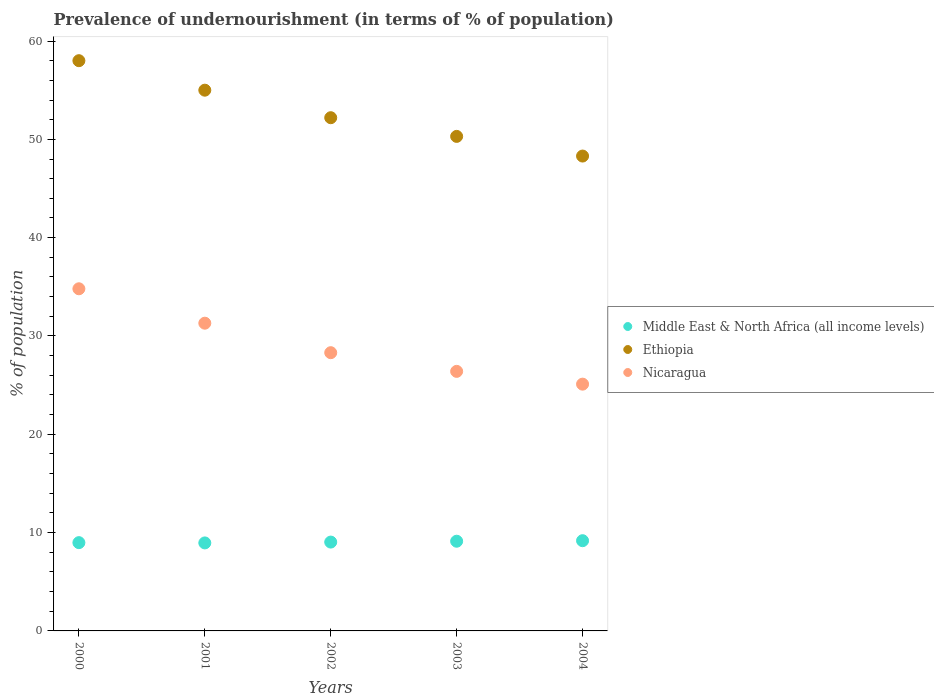How many different coloured dotlines are there?
Offer a terse response. 3. Is the number of dotlines equal to the number of legend labels?
Your response must be concise. Yes. What is the percentage of undernourished population in Middle East & North Africa (all income levels) in 2000?
Give a very brief answer. 8.98. Across all years, what is the maximum percentage of undernourished population in Ethiopia?
Ensure brevity in your answer.  58. Across all years, what is the minimum percentage of undernourished population in Ethiopia?
Your answer should be compact. 48.3. In which year was the percentage of undernourished population in Ethiopia minimum?
Your answer should be very brief. 2004. What is the total percentage of undernourished population in Middle East & North Africa (all income levels) in the graph?
Ensure brevity in your answer.  45.27. What is the difference between the percentage of undernourished population in Middle East & North Africa (all income levels) in 2003 and that in 2004?
Give a very brief answer. -0.05. What is the difference between the percentage of undernourished population in Ethiopia in 2004 and the percentage of undernourished population in Middle East & North Africa (all income levels) in 2001?
Your answer should be compact. 39.35. What is the average percentage of undernourished population in Ethiopia per year?
Ensure brevity in your answer.  52.76. In the year 2002, what is the difference between the percentage of undernourished population in Ethiopia and percentage of undernourished population in Middle East & North Africa (all income levels)?
Your answer should be compact. 43.16. What is the ratio of the percentage of undernourished population in Ethiopia in 2002 to that in 2004?
Your answer should be compact. 1.08. Is the difference between the percentage of undernourished population in Ethiopia in 2003 and 2004 greater than the difference between the percentage of undernourished population in Middle East & North Africa (all income levels) in 2003 and 2004?
Keep it short and to the point. Yes. What is the difference between the highest and the second highest percentage of undernourished population in Nicaragua?
Your answer should be very brief. 3.5. What is the difference between the highest and the lowest percentage of undernourished population in Ethiopia?
Ensure brevity in your answer.  9.7. Is the percentage of undernourished population in Middle East & North Africa (all income levels) strictly greater than the percentage of undernourished population in Ethiopia over the years?
Offer a terse response. No. How many dotlines are there?
Keep it short and to the point. 3. Does the graph contain grids?
Provide a succinct answer. No. How many legend labels are there?
Provide a short and direct response. 3. How are the legend labels stacked?
Offer a very short reply. Vertical. What is the title of the graph?
Give a very brief answer. Prevalence of undernourishment (in terms of % of population). Does "Spain" appear as one of the legend labels in the graph?
Offer a very short reply. No. What is the label or title of the Y-axis?
Your response must be concise. % of population. What is the % of population of Middle East & North Africa (all income levels) in 2000?
Keep it short and to the point. 8.98. What is the % of population of Ethiopia in 2000?
Give a very brief answer. 58. What is the % of population of Nicaragua in 2000?
Keep it short and to the point. 34.8. What is the % of population of Middle East & North Africa (all income levels) in 2001?
Offer a terse response. 8.95. What is the % of population in Ethiopia in 2001?
Offer a terse response. 55. What is the % of population in Nicaragua in 2001?
Your response must be concise. 31.3. What is the % of population in Middle East & North Africa (all income levels) in 2002?
Give a very brief answer. 9.04. What is the % of population of Ethiopia in 2002?
Offer a terse response. 52.2. What is the % of population in Nicaragua in 2002?
Give a very brief answer. 28.3. What is the % of population in Middle East & North Africa (all income levels) in 2003?
Your answer should be very brief. 9.12. What is the % of population of Ethiopia in 2003?
Provide a succinct answer. 50.3. What is the % of population of Nicaragua in 2003?
Provide a short and direct response. 26.4. What is the % of population of Middle East & North Africa (all income levels) in 2004?
Offer a terse response. 9.18. What is the % of population in Ethiopia in 2004?
Your answer should be compact. 48.3. What is the % of population of Nicaragua in 2004?
Provide a short and direct response. 25.1. Across all years, what is the maximum % of population of Middle East & North Africa (all income levels)?
Provide a succinct answer. 9.18. Across all years, what is the maximum % of population of Nicaragua?
Make the answer very short. 34.8. Across all years, what is the minimum % of population of Middle East & North Africa (all income levels)?
Offer a very short reply. 8.95. Across all years, what is the minimum % of population in Ethiopia?
Give a very brief answer. 48.3. Across all years, what is the minimum % of population in Nicaragua?
Your answer should be compact. 25.1. What is the total % of population of Middle East & North Africa (all income levels) in the graph?
Your answer should be very brief. 45.27. What is the total % of population in Ethiopia in the graph?
Make the answer very short. 263.8. What is the total % of population of Nicaragua in the graph?
Ensure brevity in your answer.  145.9. What is the difference between the % of population in Middle East & North Africa (all income levels) in 2000 and that in 2001?
Your answer should be compact. 0.03. What is the difference between the % of population of Nicaragua in 2000 and that in 2001?
Your answer should be very brief. 3.5. What is the difference between the % of population of Middle East & North Africa (all income levels) in 2000 and that in 2002?
Make the answer very short. -0.06. What is the difference between the % of population of Ethiopia in 2000 and that in 2002?
Offer a terse response. 5.8. What is the difference between the % of population in Middle East & North Africa (all income levels) in 2000 and that in 2003?
Provide a succinct answer. -0.14. What is the difference between the % of population in Middle East & North Africa (all income levels) in 2000 and that in 2004?
Ensure brevity in your answer.  -0.2. What is the difference between the % of population in Ethiopia in 2000 and that in 2004?
Give a very brief answer. 9.7. What is the difference between the % of population of Middle East & North Africa (all income levels) in 2001 and that in 2002?
Ensure brevity in your answer.  -0.09. What is the difference between the % of population of Nicaragua in 2001 and that in 2002?
Provide a succinct answer. 3. What is the difference between the % of population of Middle East & North Africa (all income levels) in 2001 and that in 2003?
Provide a short and direct response. -0.17. What is the difference between the % of population of Middle East & North Africa (all income levels) in 2001 and that in 2004?
Keep it short and to the point. -0.23. What is the difference between the % of population in Nicaragua in 2001 and that in 2004?
Your response must be concise. 6.2. What is the difference between the % of population of Middle East & North Africa (all income levels) in 2002 and that in 2003?
Keep it short and to the point. -0.09. What is the difference between the % of population of Ethiopia in 2002 and that in 2003?
Make the answer very short. 1.9. What is the difference between the % of population in Nicaragua in 2002 and that in 2003?
Make the answer very short. 1.9. What is the difference between the % of population in Middle East & North Africa (all income levels) in 2002 and that in 2004?
Give a very brief answer. -0.14. What is the difference between the % of population in Middle East & North Africa (all income levels) in 2003 and that in 2004?
Offer a terse response. -0.05. What is the difference between the % of population in Ethiopia in 2003 and that in 2004?
Make the answer very short. 2. What is the difference between the % of population of Middle East & North Africa (all income levels) in 2000 and the % of population of Ethiopia in 2001?
Keep it short and to the point. -46.02. What is the difference between the % of population of Middle East & North Africa (all income levels) in 2000 and the % of population of Nicaragua in 2001?
Provide a short and direct response. -22.32. What is the difference between the % of population in Ethiopia in 2000 and the % of population in Nicaragua in 2001?
Keep it short and to the point. 26.7. What is the difference between the % of population of Middle East & North Africa (all income levels) in 2000 and the % of population of Ethiopia in 2002?
Give a very brief answer. -43.22. What is the difference between the % of population in Middle East & North Africa (all income levels) in 2000 and the % of population in Nicaragua in 2002?
Keep it short and to the point. -19.32. What is the difference between the % of population in Ethiopia in 2000 and the % of population in Nicaragua in 2002?
Give a very brief answer. 29.7. What is the difference between the % of population in Middle East & North Africa (all income levels) in 2000 and the % of population in Ethiopia in 2003?
Provide a short and direct response. -41.32. What is the difference between the % of population of Middle East & North Africa (all income levels) in 2000 and the % of population of Nicaragua in 2003?
Ensure brevity in your answer.  -17.42. What is the difference between the % of population in Ethiopia in 2000 and the % of population in Nicaragua in 2003?
Give a very brief answer. 31.6. What is the difference between the % of population in Middle East & North Africa (all income levels) in 2000 and the % of population in Ethiopia in 2004?
Keep it short and to the point. -39.32. What is the difference between the % of population of Middle East & North Africa (all income levels) in 2000 and the % of population of Nicaragua in 2004?
Offer a very short reply. -16.12. What is the difference between the % of population in Ethiopia in 2000 and the % of population in Nicaragua in 2004?
Offer a terse response. 32.9. What is the difference between the % of population of Middle East & North Africa (all income levels) in 2001 and the % of population of Ethiopia in 2002?
Provide a short and direct response. -43.25. What is the difference between the % of population in Middle East & North Africa (all income levels) in 2001 and the % of population in Nicaragua in 2002?
Your answer should be compact. -19.35. What is the difference between the % of population of Ethiopia in 2001 and the % of population of Nicaragua in 2002?
Provide a short and direct response. 26.7. What is the difference between the % of population in Middle East & North Africa (all income levels) in 2001 and the % of population in Ethiopia in 2003?
Give a very brief answer. -41.35. What is the difference between the % of population of Middle East & North Africa (all income levels) in 2001 and the % of population of Nicaragua in 2003?
Make the answer very short. -17.45. What is the difference between the % of population of Ethiopia in 2001 and the % of population of Nicaragua in 2003?
Ensure brevity in your answer.  28.6. What is the difference between the % of population of Middle East & North Africa (all income levels) in 2001 and the % of population of Ethiopia in 2004?
Ensure brevity in your answer.  -39.35. What is the difference between the % of population of Middle East & North Africa (all income levels) in 2001 and the % of population of Nicaragua in 2004?
Offer a terse response. -16.15. What is the difference between the % of population in Ethiopia in 2001 and the % of population in Nicaragua in 2004?
Offer a very short reply. 29.9. What is the difference between the % of population of Middle East & North Africa (all income levels) in 2002 and the % of population of Ethiopia in 2003?
Ensure brevity in your answer.  -41.26. What is the difference between the % of population of Middle East & North Africa (all income levels) in 2002 and the % of population of Nicaragua in 2003?
Offer a very short reply. -17.36. What is the difference between the % of population in Ethiopia in 2002 and the % of population in Nicaragua in 2003?
Provide a succinct answer. 25.8. What is the difference between the % of population of Middle East & North Africa (all income levels) in 2002 and the % of population of Ethiopia in 2004?
Provide a succinct answer. -39.26. What is the difference between the % of population of Middle East & North Africa (all income levels) in 2002 and the % of population of Nicaragua in 2004?
Your answer should be compact. -16.06. What is the difference between the % of population of Ethiopia in 2002 and the % of population of Nicaragua in 2004?
Provide a succinct answer. 27.1. What is the difference between the % of population in Middle East & North Africa (all income levels) in 2003 and the % of population in Ethiopia in 2004?
Your answer should be very brief. -39.18. What is the difference between the % of population in Middle East & North Africa (all income levels) in 2003 and the % of population in Nicaragua in 2004?
Your answer should be very brief. -15.98. What is the difference between the % of population in Ethiopia in 2003 and the % of population in Nicaragua in 2004?
Provide a succinct answer. 25.2. What is the average % of population in Middle East & North Africa (all income levels) per year?
Your answer should be very brief. 9.05. What is the average % of population of Ethiopia per year?
Your answer should be very brief. 52.76. What is the average % of population in Nicaragua per year?
Ensure brevity in your answer.  29.18. In the year 2000, what is the difference between the % of population in Middle East & North Africa (all income levels) and % of population in Ethiopia?
Your answer should be very brief. -49.02. In the year 2000, what is the difference between the % of population of Middle East & North Africa (all income levels) and % of population of Nicaragua?
Your answer should be very brief. -25.82. In the year 2000, what is the difference between the % of population in Ethiopia and % of population in Nicaragua?
Your answer should be compact. 23.2. In the year 2001, what is the difference between the % of population of Middle East & North Africa (all income levels) and % of population of Ethiopia?
Offer a terse response. -46.05. In the year 2001, what is the difference between the % of population in Middle East & North Africa (all income levels) and % of population in Nicaragua?
Make the answer very short. -22.35. In the year 2001, what is the difference between the % of population of Ethiopia and % of population of Nicaragua?
Offer a terse response. 23.7. In the year 2002, what is the difference between the % of population in Middle East & North Africa (all income levels) and % of population in Ethiopia?
Ensure brevity in your answer.  -43.16. In the year 2002, what is the difference between the % of population of Middle East & North Africa (all income levels) and % of population of Nicaragua?
Your response must be concise. -19.26. In the year 2002, what is the difference between the % of population of Ethiopia and % of population of Nicaragua?
Your answer should be very brief. 23.9. In the year 2003, what is the difference between the % of population in Middle East & North Africa (all income levels) and % of population in Ethiopia?
Offer a very short reply. -41.18. In the year 2003, what is the difference between the % of population in Middle East & North Africa (all income levels) and % of population in Nicaragua?
Ensure brevity in your answer.  -17.28. In the year 2003, what is the difference between the % of population in Ethiopia and % of population in Nicaragua?
Provide a succinct answer. 23.9. In the year 2004, what is the difference between the % of population of Middle East & North Africa (all income levels) and % of population of Ethiopia?
Make the answer very short. -39.12. In the year 2004, what is the difference between the % of population of Middle East & North Africa (all income levels) and % of population of Nicaragua?
Provide a succinct answer. -15.92. In the year 2004, what is the difference between the % of population of Ethiopia and % of population of Nicaragua?
Offer a terse response. 23.2. What is the ratio of the % of population in Ethiopia in 2000 to that in 2001?
Give a very brief answer. 1.05. What is the ratio of the % of population in Nicaragua in 2000 to that in 2001?
Your answer should be very brief. 1.11. What is the ratio of the % of population of Nicaragua in 2000 to that in 2002?
Keep it short and to the point. 1.23. What is the ratio of the % of population in Middle East & North Africa (all income levels) in 2000 to that in 2003?
Ensure brevity in your answer.  0.98. What is the ratio of the % of population of Ethiopia in 2000 to that in 2003?
Your answer should be very brief. 1.15. What is the ratio of the % of population in Nicaragua in 2000 to that in 2003?
Provide a short and direct response. 1.32. What is the ratio of the % of population in Middle East & North Africa (all income levels) in 2000 to that in 2004?
Make the answer very short. 0.98. What is the ratio of the % of population of Ethiopia in 2000 to that in 2004?
Your answer should be compact. 1.2. What is the ratio of the % of population in Nicaragua in 2000 to that in 2004?
Give a very brief answer. 1.39. What is the ratio of the % of population of Ethiopia in 2001 to that in 2002?
Provide a succinct answer. 1.05. What is the ratio of the % of population of Nicaragua in 2001 to that in 2002?
Provide a succinct answer. 1.11. What is the ratio of the % of population of Middle East & North Africa (all income levels) in 2001 to that in 2003?
Ensure brevity in your answer.  0.98. What is the ratio of the % of population of Ethiopia in 2001 to that in 2003?
Ensure brevity in your answer.  1.09. What is the ratio of the % of population of Nicaragua in 2001 to that in 2003?
Keep it short and to the point. 1.19. What is the ratio of the % of population of Middle East & North Africa (all income levels) in 2001 to that in 2004?
Keep it short and to the point. 0.98. What is the ratio of the % of population of Ethiopia in 2001 to that in 2004?
Provide a succinct answer. 1.14. What is the ratio of the % of population of Nicaragua in 2001 to that in 2004?
Your answer should be compact. 1.25. What is the ratio of the % of population in Middle East & North Africa (all income levels) in 2002 to that in 2003?
Keep it short and to the point. 0.99. What is the ratio of the % of population in Ethiopia in 2002 to that in 2003?
Provide a short and direct response. 1.04. What is the ratio of the % of population in Nicaragua in 2002 to that in 2003?
Provide a short and direct response. 1.07. What is the ratio of the % of population in Middle East & North Africa (all income levels) in 2002 to that in 2004?
Give a very brief answer. 0.98. What is the ratio of the % of population of Ethiopia in 2002 to that in 2004?
Your answer should be compact. 1.08. What is the ratio of the % of population of Nicaragua in 2002 to that in 2004?
Offer a terse response. 1.13. What is the ratio of the % of population of Middle East & North Africa (all income levels) in 2003 to that in 2004?
Provide a short and direct response. 0.99. What is the ratio of the % of population in Ethiopia in 2003 to that in 2004?
Give a very brief answer. 1.04. What is the ratio of the % of population of Nicaragua in 2003 to that in 2004?
Your answer should be compact. 1.05. What is the difference between the highest and the second highest % of population of Middle East & North Africa (all income levels)?
Provide a short and direct response. 0.05. What is the difference between the highest and the lowest % of population in Middle East & North Africa (all income levels)?
Keep it short and to the point. 0.23. What is the difference between the highest and the lowest % of population in Ethiopia?
Provide a short and direct response. 9.7. What is the difference between the highest and the lowest % of population of Nicaragua?
Your answer should be very brief. 9.7. 